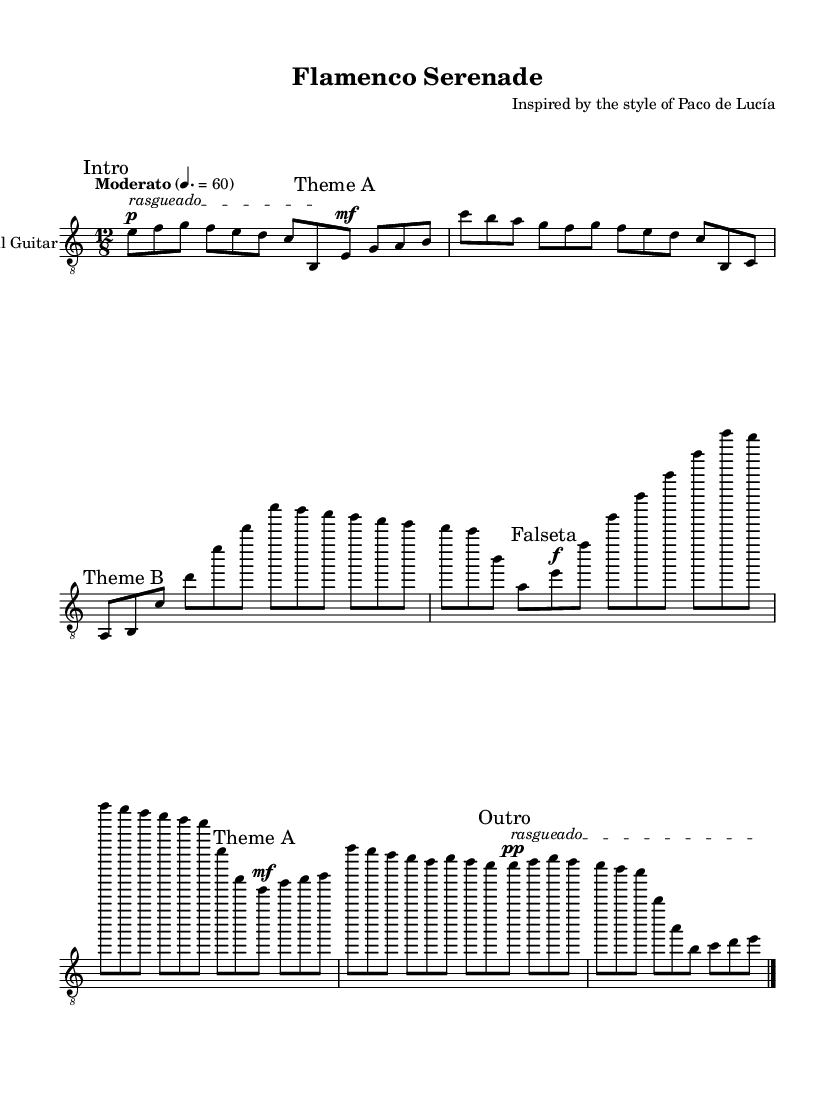What is the key signature of this music? The music is in E Phrygian, which has one flat (D). Phrygian mode is derived from the major scale and is characterized by a minor second interval between the first and second degrees.
Answer: E Phrygian What is the time signature of this composition? The time signature is 12/8, indicating a compound time signature where there are four beats per measure, each divided into three eighth notes. This can be seen in the initial notation next to the key signature.
Answer: 12/8 What is the tempo marking of the piece? The tempo marking indicates "Moderato" with a quarter note equaling 60 beats per minute. This signifies a moderate pace for the performance.
Answer: Moderato How many distinct sections are present in the piece? The piece includes six distinct sections: Intro, Theme A, Theme B, Falseta, Theme A (abbreviated), and Outro. This can be determined by the markings indicated throughout the score.
Answer: Six What dynamic marking is associated with the 'Falseta' section? The 'Falseta' section starts with a dynamic marking of forte (f), indicating it should be played loudly. This can be identified in the notation preceding this section.
Answer: Forte Which playing technique is noted in the 'Intro' and 'Outro' sections? The playing technique noted in both the 'Intro' and 'Outro' sections is "rasgueado," a strumming method commonly used in flamenco guitar playing. This is indicated with text markings in the score.
Answer: Rasgueado 